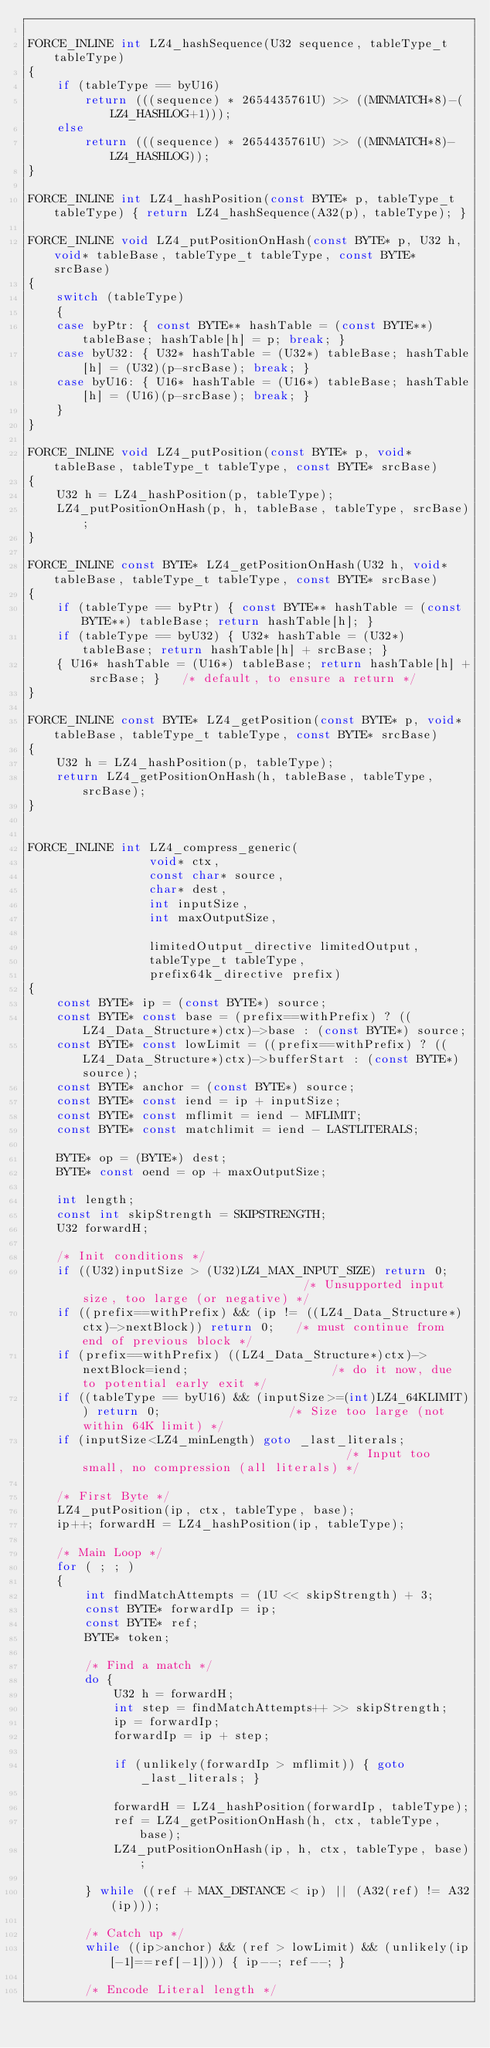<code> <loc_0><loc_0><loc_500><loc_500><_C_>
FORCE_INLINE int LZ4_hashSequence(U32 sequence, tableType_t tableType)
{
    if (tableType == byU16)
        return (((sequence) * 2654435761U) >> ((MINMATCH*8)-(LZ4_HASHLOG+1)));
    else
        return (((sequence) * 2654435761U) >> ((MINMATCH*8)-LZ4_HASHLOG));
}

FORCE_INLINE int LZ4_hashPosition(const BYTE* p, tableType_t tableType) { return LZ4_hashSequence(A32(p), tableType); }

FORCE_INLINE void LZ4_putPositionOnHash(const BYTE* p, U32 h, void* tableBase, tableType_t tableType, const BYTE* srcBase)
{
    switch (tableType)
    {
    case byPtr: { const BYTE** hashTable = (const BYTE**) tableBase; hashTable[h] = p; break; }
    case byU32: { U32* hashTable = (U32*) tableBase; hashTable[h] = (U32)(p-srcBase); break; }
    case byU16: { U16* hashTable = (U16*) tableBase; hashTable[h] = (U16)(p-srcBase); break; }
    }
}

FORCE_INLINE void LZ4_putPosition(const BYTE* p, void* tableBase, tableType_t tableType, const BYTE* srcBase)
{
    U32 h = LZ4_hashPosition(p, tableType);
    LZ4_putPositionOnHash(p, h, tableBase, tableType, srcBase);
}

FORCE_INLINE const BYTE* LZ4_getPositionOnHash(U32 h, void* tableBase, tableType_t tableType, const BYTE* srcBase)
{
    if (tableType == byPtr) { const BYTE** hashTable = (const BYTE**) tableBase; return hashTable[h]; }
    if (tableType == byU32) { U32* hashTable = (U32*) tableBase; return hashTable[h] + srcBase; }
    { U16* hashTable = (U16*) tableBase; return hashTable[h] + srcBase; }   /* default, to ensure a return */
}

FORCE_INLINE const BYTE* LZ4_getPosition(const BYTE* p, void* tableBase, tableType_t tableType, const BYTE* srcBase)
{
    U32 h = LZ4_hashPosition(p, tableType);
    return LZ4_getPositionOnHash(h, tableBase, tableType, srcBase);
}


FORCE_INLINE int LZ4_compress_generic(
                 void* ctx,
                 const char* source,
                 char* dest,
                 int inputSize,
                 int maxOutputSize,

                 limitedOutput_directive limitedOutput,
                 tableType_t tableType,
                 prefix64k_directive prefix)
{
    const BYTE* ip = (const BYTE*) source;
    const BYTE* const base = (prefix==withPrefix) ? ((LZ4_Data_Structure*)ctx)->base : (const BYTE*) source;
    const BYTE* const lowLimit = ((prefix==withPrefix) ? ((LZ4_Data_Structure*)ctx)->bufferStart : (const BYTE*)source);
    const BYTE* anchor = (const BYTE*) source;
    const BYTE* const iend = ip + inputSize;
    const BYTE* const mflimit = iend - MFLIMIT;
    const BYTE* const matchlimit = iend - LASTLITERALS;

    BYTE* op = (BYTE*) dest;
    BYTE* const oend = op + maxOutputSize;

    int length;
    const int skipStrength = SKIPSTRENGTH;
    U32 forwardH;

    /* Init conditions */
    if ((U32)inputSize > (U32)LZ4_MAX_INPUT_SIZE) return 0;                                /* Unsupported input size, too large (or negative) */
    if ((prefix==withPrefix) && (ip != ((LZ4_Data_Structure*)ctx)->nextBlock)) return 0;   /* must continue from end of previous block */
    if (prefix==withPrefix) ((LZ4_Data_Structure*)ctx)->nextBlock=iend;                    /* do it now, due to potential early exit */
    if ((tableType == byU16) && (inputSize>=(int)LZ4_64KLIMIT)) return 0;                  /* Size too large (not within 64K limit) */
    if (inputSize<LZ4_minLength) goto _last_literals;                                      /* Input too small, no compression (all literals) */

    /* First Byte */
    LZ4_putPosition(ip, ctx, tableType, base);
    ip++; forwardH = LZ4_hashPosition(ip, tableType);

    /* Main Loop */
    for ( ; ; )
    {
        int findMatchAttempts = (1U << skipStrength) + 3;
        const BYTE* forwardIp = ip;
        const BYTE* ref;
        BYTE* token;

        /* Find a match */
        do {
            U32 h = forwardH;
            int step = findMatchAttempts++ >> skipStrength;
            ip = forwardIp;
            forwardIp = ip + step;

            if (unlikely(forwardIp > mflimit)) { goto _last_literals; }

            forwardH = LZ4_hashPosition(forwardIp, tableType);
            ref = LZ4_getPositionOnHash(h, ctx, tableType, base);
            LZ4_putPositionOnHash(ip, h, ctx, tableType, base);

        } while ((ref + MAX_DISTANCE < ip) || (A32(ref) != A32(ip)));

        /* Catch up */
        while ((ip>anchor) && (ref > lowLimit) && (unlikely(ip[-1]==ref[-1]))) { ip--; ref--; }

        /* Encode Literal length */</code> 